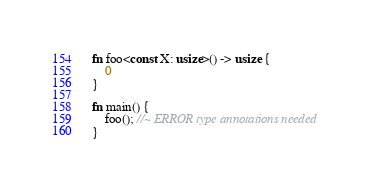Convert code to text. <code><loc_0><loc_0><loc_500><loc_500><_Rust_>fn foo<const X: usize>() -> usize {
    0
}

fn main() {
    foo(); //~ ERROR type annotations needed
}
</code> 